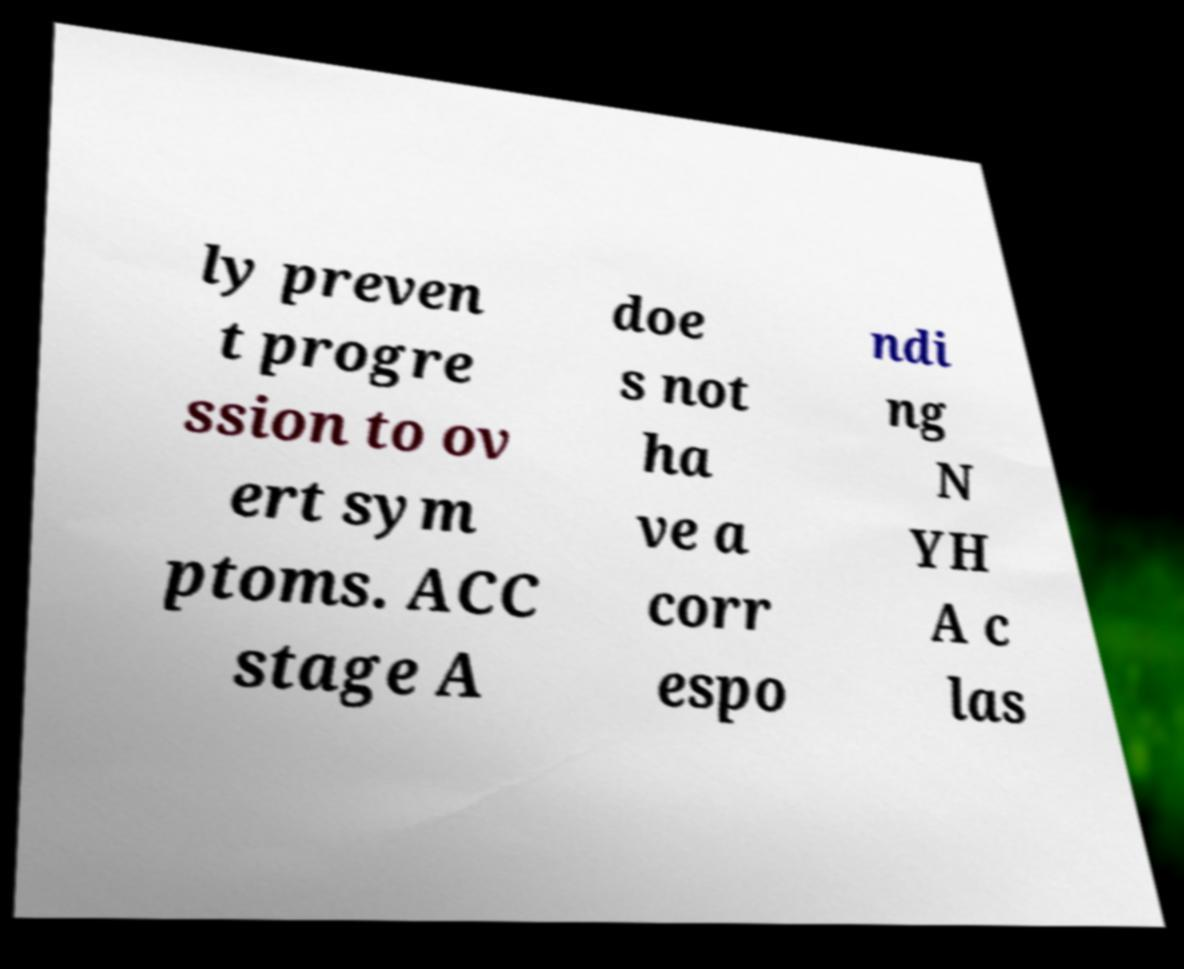There's text embedded in this image that I need extracted. Can you transcribe it verbatim? ly preven t progre ssion to ov ert sym ptoms. ACC stage A doe s not ha ve a corr espo ndi ng N YH A c las 